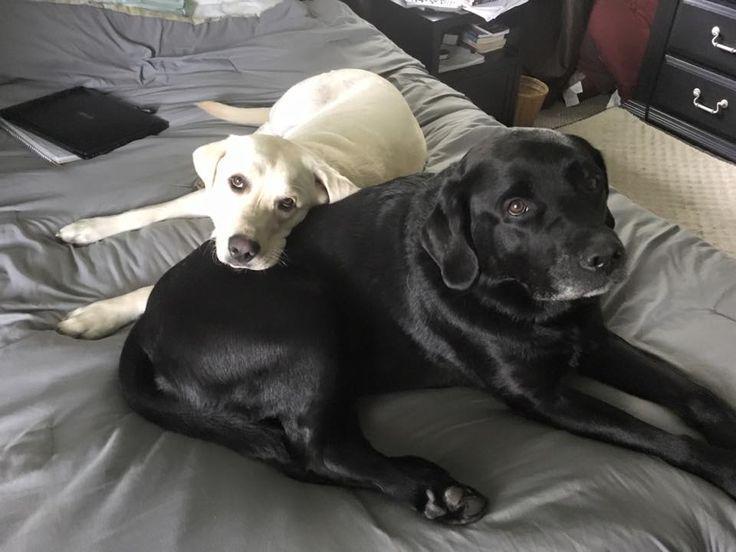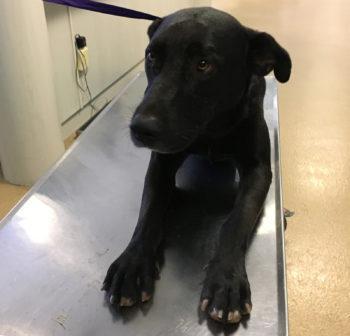The first image is the image on the left, the second image is the image on the right. For the images displayed, is the sentence "An image featuring reclining labrador retrievers includes one """"blond"""" dog." factually correct? Answer yes or no. Yes. The first image is the image on the left, the second image is the image on the right. Assess this claim about the two images: "The left image contains no more than one dog.". Correct or not? Answer yes or no. No. 